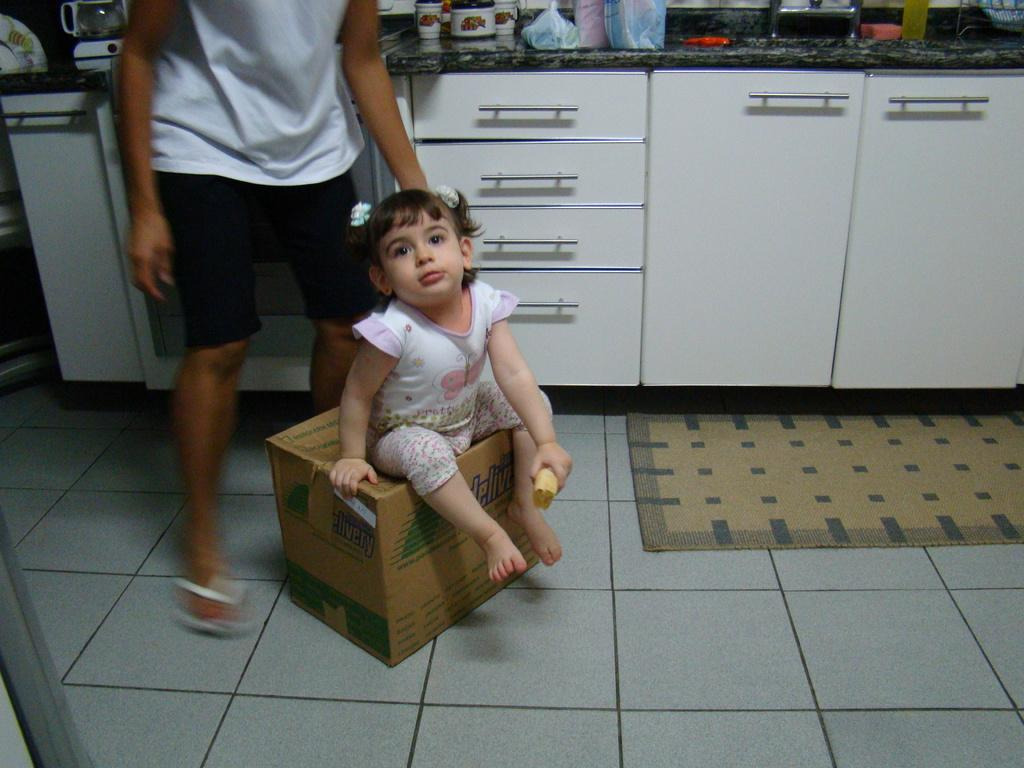<image>
Offer a succinct explanation of the picture presented. a girl sitting on a cardboard box labeled 'delivery' 